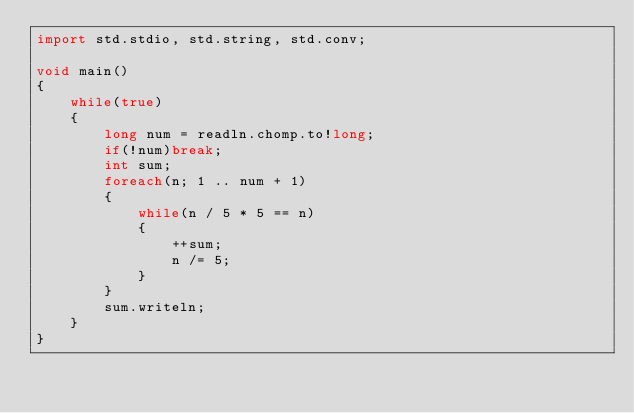<code> <loc_0><loc_0><loc_500><loc_500><_D_>import std.stdio, std.string, std.conv;

void main()
{
    while(true)
    {
        long num = readln.chomp.to!long;
        if(!num)break;
        int sum;
        foreach(n; 1 .. num + 1)
        {
            while(n / 5 * 5 == n)
            {
                ++sum;
                n /= 5;
            }
        }
        sum.writeln;
    }
}</code> 